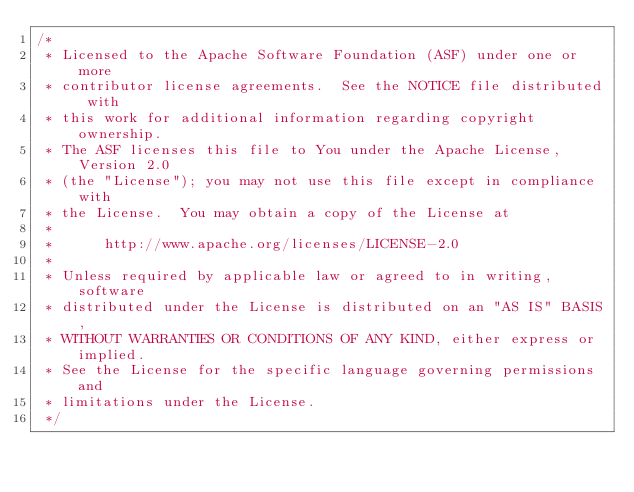<code> <loc_0><loc_0><loc_500><loc_500><_Java_>/*
 * Licensed to the Apache Software Foundation (ASF) under one or more
 * contributor license agreements.  See the NOTICE file distributed with
 * this work for additional information regarding copyright ownership.
 * The ASF licenses this file to You under the Apache License, Version 2.0
 * (the "License"); you may not use this file except in compliance with
 * the License.  You may obtain a copy of the License at
 *
 *      http://www.apache.org/licenses/LICENSE-2.0
 *
 * Unless required by applicable law or agreed to in writing, software
 * distributed under the License is distributed on an "AS IS" BASIS,
 * WITHOUT WARRANTIES OR CONDITIONS OF ANY KIND, either express or implied.
 * See the License for the specific language governing permissions and
 * limitations under the License.
 */</code> 